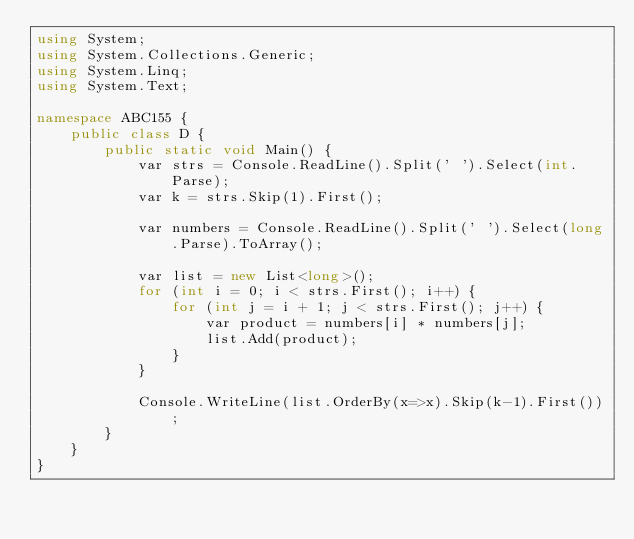Convert code to text. <code><loc_0><loc_0><loc_500><loc_500><_C#_>using System;
using System.Collections.Generic;
using System.Linq;
using System.Text;

namespace ABC155 {
    public class D {
        public static void Main() {
            var strs = Console.ReadLine().Split(' ').Select(int.Parse);
            var k = strs.Skip(1).First();

            var numbers = Console.ReadLine().Split(' ').Select(long.Parse).ToArray();

            var list = new List<long>();
            for (int i = 0; i < strs.First(); i++) {
                for (int j = i + 1; j < strs.First(); j++) {
                    var product = numbers[i] * numbers[j];
                    list.Add(product);
                }
            }

            Console.WriteLine(list.OrderBy(x=>x).Skip(k-1).First());
        }
    }
}
</code> 